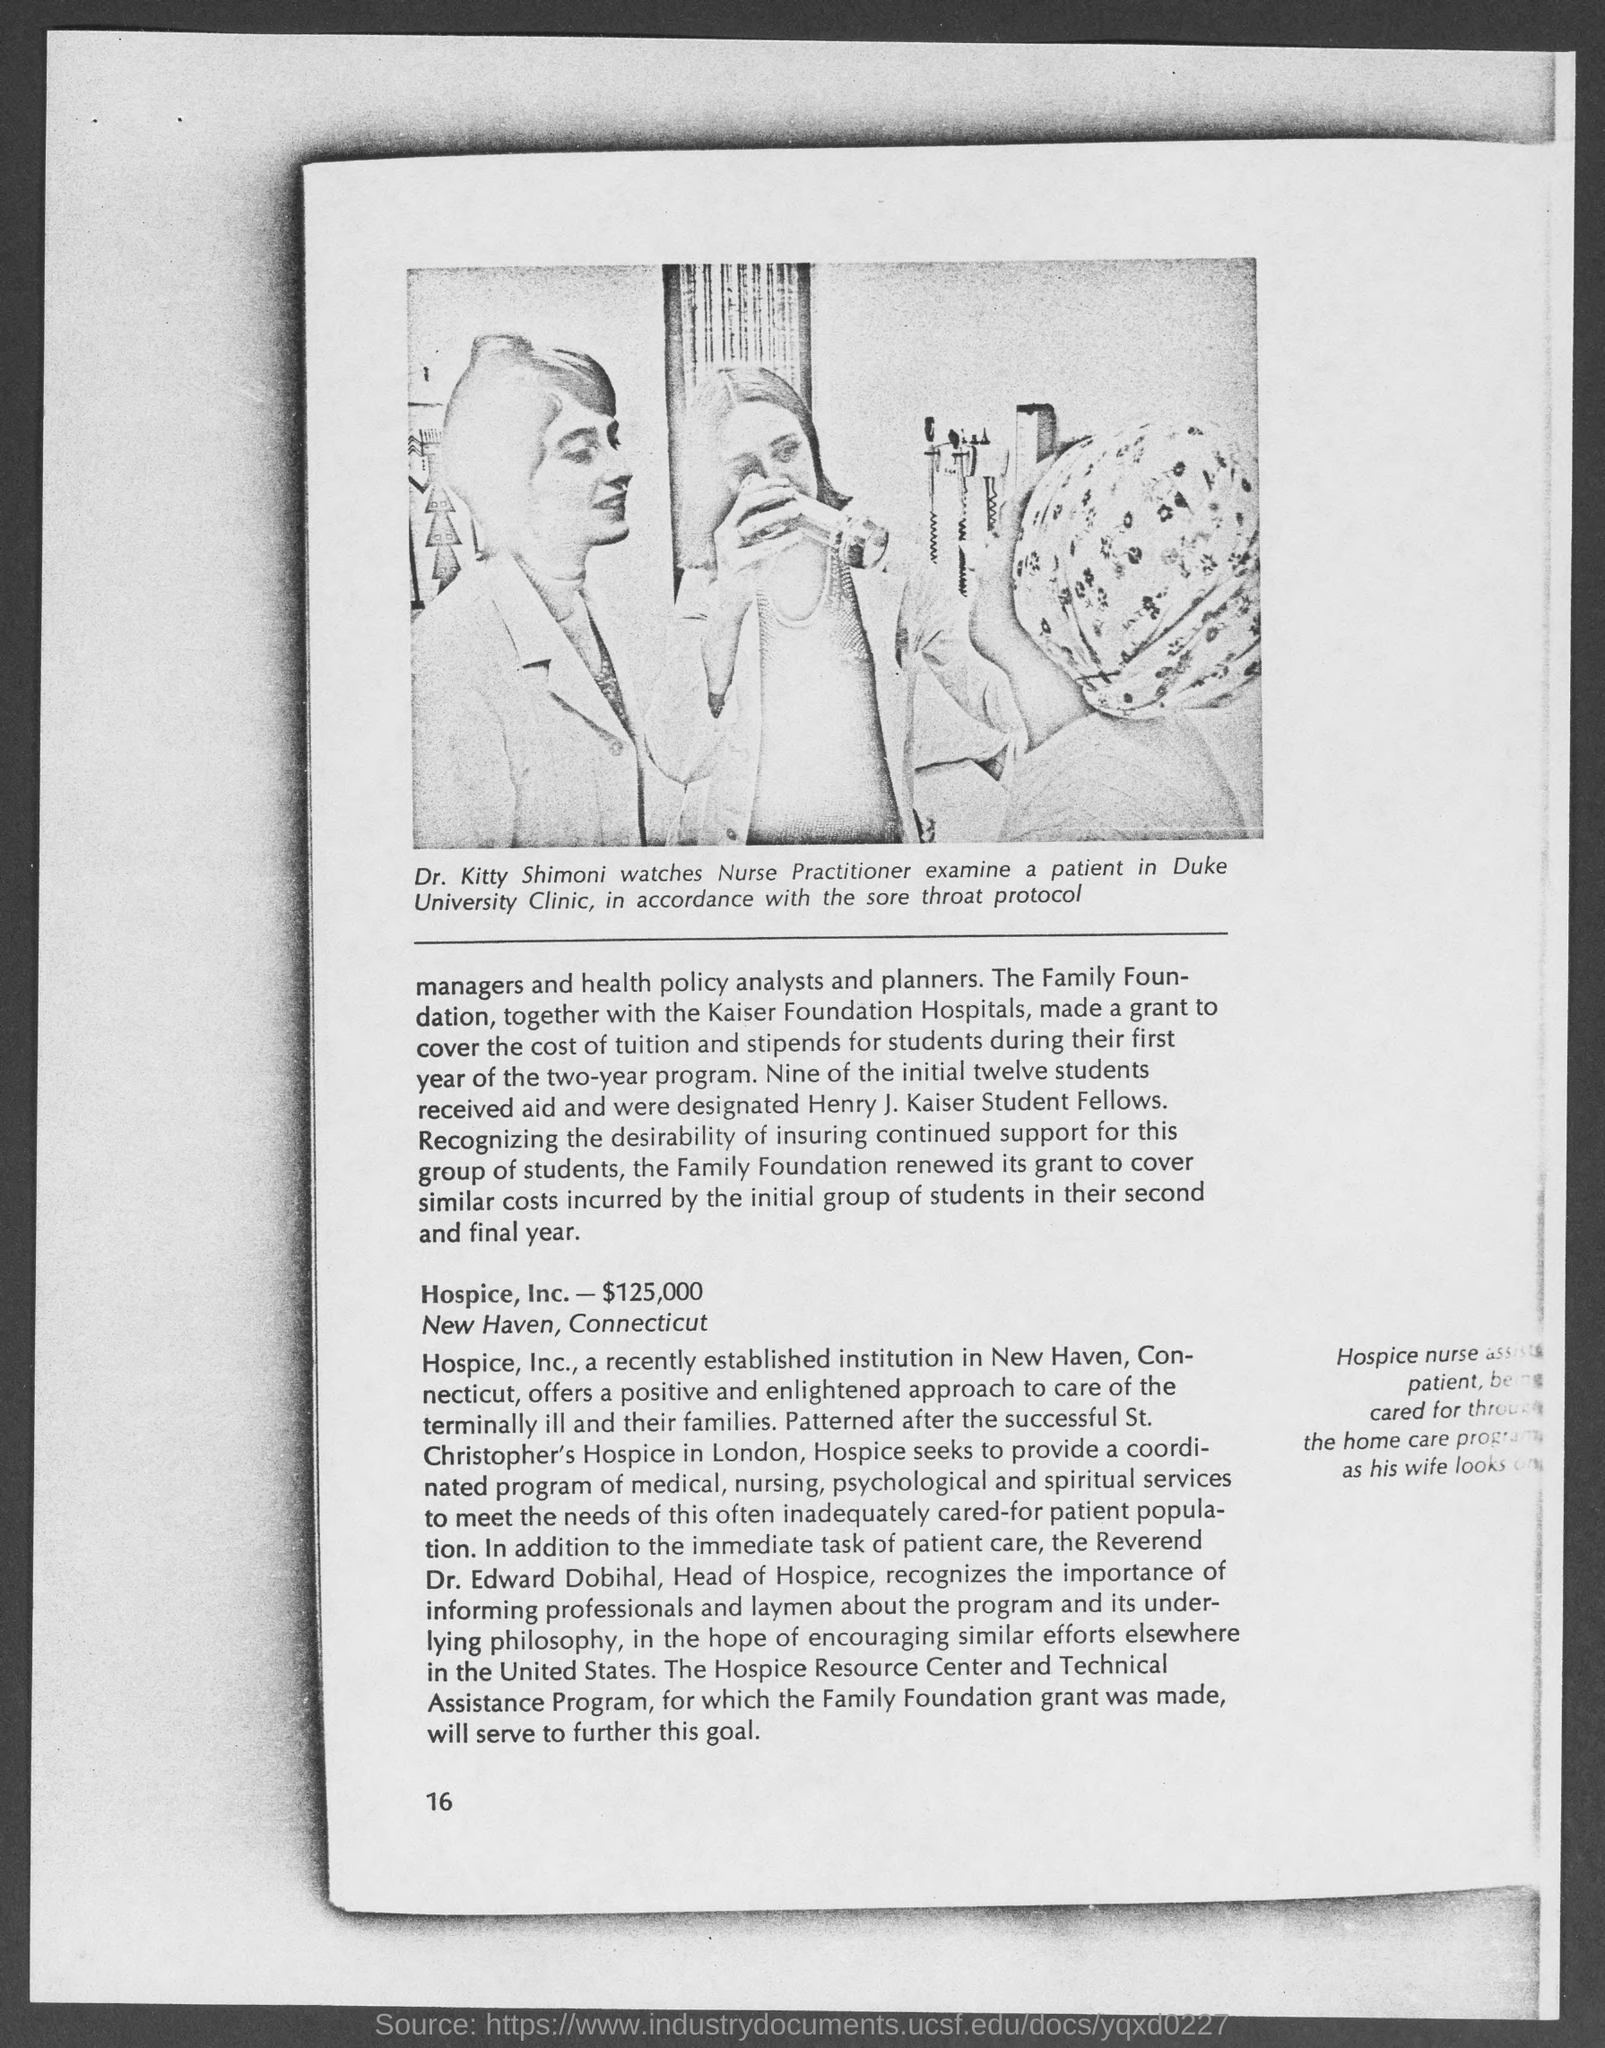Outline some significant characteristics in this image. The family foundation, in collaboration with Kaiser Foundation Hospitals, provided a grant to cover the tuition and stipends for students. The patient was examined in the Duke University clinic. Hospice, Inc. is located in New Haven, Connecticut. Nine students were designated as Henry J. Kaiser student fellows. The person in the photograph is identified as Dr. Kitty Shimoni. 